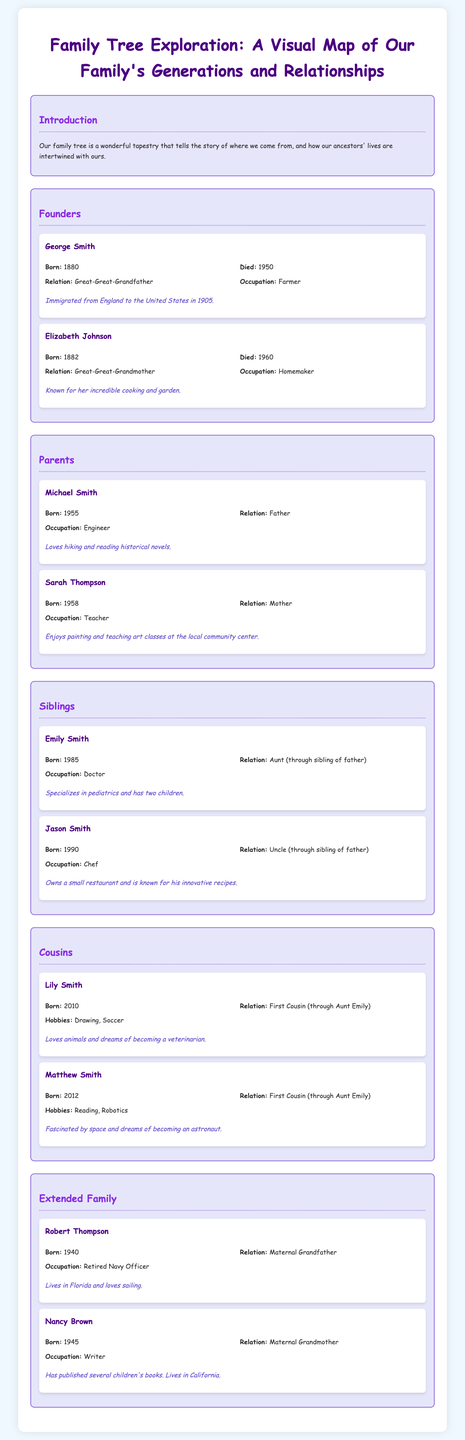What year was George Smith born? The document states that George Smith was born in 1880.
Answer: 1880 What is the occupation of Sarah Thompson? The document lists Sarah Thompson's occupation as a Teacher.
Answer: Teacher Who is the maternal grandmother? The document identifies Nancy Brown as the maternal grandmother.
Answer: Nancy Brown How many children does Emily Smith have? It is mentioned in the document that Emily Smith has two children.
Answer: two What year did Elizabeth Johnson die? The document states that Elizabeth Johnson died in 1960.
Answer: 1960 Which family member specializes in pediatrics? The document indicates that Emily Smith specializes in pediatrics.
Answer: Emily Smith How are Matthew Smith and Lily Smith related? The document describes Matthew Smith and Lily Smith as First Cousins through Aunt Emily.
Answer: First Cousins Who immigrated from England? The document notes that George Smith immigrated from England to the United States in 1905.
Answer: George Smith 